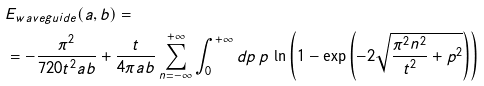Convert formula to latex. <formula><loc_0><loc_0><loc_500><loc_500>& E _ { w a v e g u i d e } ( a , b ) = \\ & = - \frac { \pi ^ { 2 } } { 7 2 0 t ^ { 2 } a b } + \frac { t } { 4 \pi a b } \sum _ { n = - \infty } ^ { + \infty } \int _ { 0 } ^ { + \infty } d p \, p \, \ln \left ( 1 - \exp \left ( - 2 \sqrt { \frac { \pi ^ { 2 } n ^ { 2 } } { t ^ { 2 } } + p ^ { 2 } } \right ) \right )</formula> 